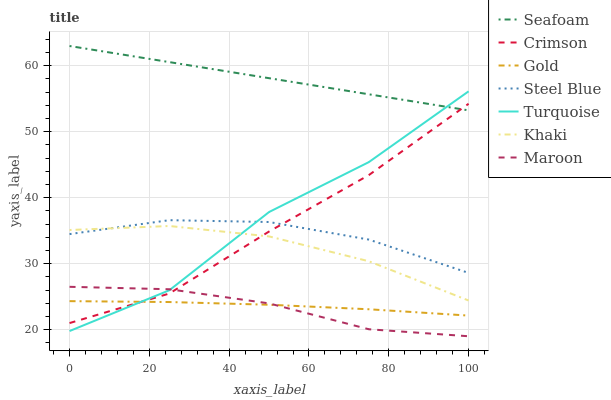Does Maroon have the minimum area under the curve?
Answer yes or no. Yes. Does Seafoam have the maximum area under the curve?
Answer yes or no. Yes. Does Khaki have the minimum area under the curve?
Answer yes or no. No. Does Khaki have the maximum area under the curve?
Answer yes or no. No. Is Seafoam the smoothest?
Answer yes or no. Yes. Is Turquoise the roughest?
Answer yes or no. Yes. Is Khaki the smoothest?
Answer yes or no. No. Is Khaki the roughest?
Answer yes or no. No. Does Maroon have the lowest value?
Answer yes or no. Yes. Does Khaki have the lowest value?
Answer yes or no. No. Does Seafoam have the highest value?
Answer yes or no. Yes. Does Khaki have the highest value?
Answer yes or no. No. Is Gold less than Steel Blue?
Answer yes or no. Yes. Is Steel Blue greater than Maroon?
Answer yes or no. Yes. Does Maroon intersect Turquoise?
Answer yes or no. Yes. Is Maroon less than Turquoise?
Answer yes or no. No. Is Maroon greater than Turquoise?
Answer yes or no. No. Does Gold intersect Steel Blue?
Answer yes or no. No. 